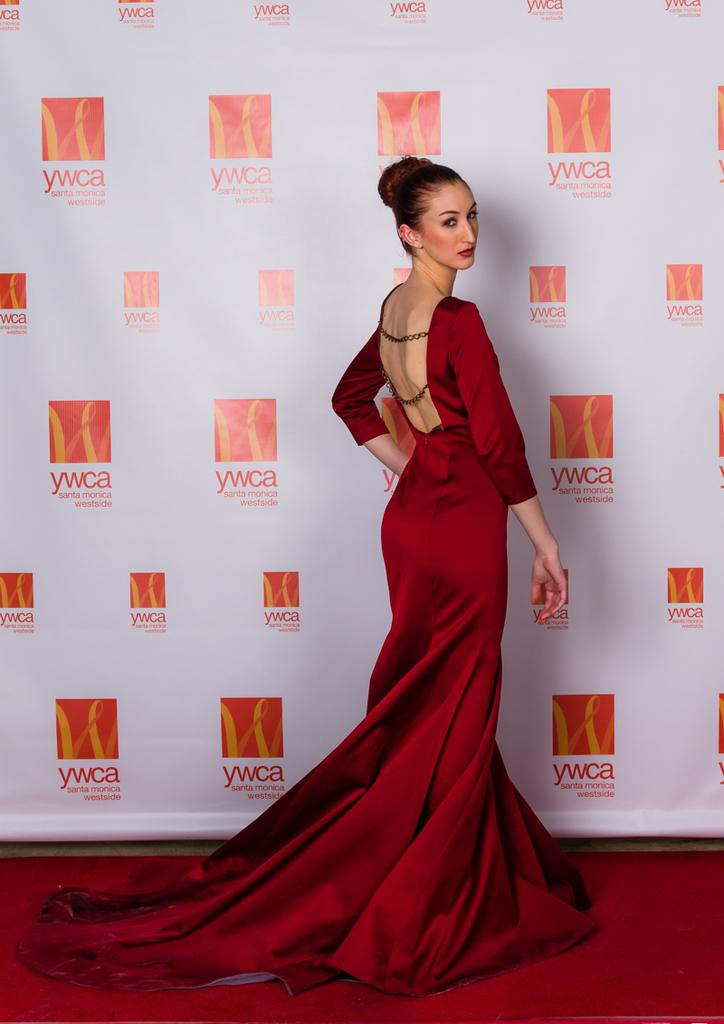What is the main subject of the image? There is a woman standing in the image. Where is the woman standing? The woman is standing on the floor. What can be seen in the background of the image? There is a banner in the background of the image. What is written on the banner? The banner has text on it. Can you tell me how many scissors are being used to cut the soda in the image? There is no soda or scissors present in the image. What type of summer activity is the woman participating in the image? The image does not depict a summer activity, nor does it provide any information about the woman's participation in any activity. 